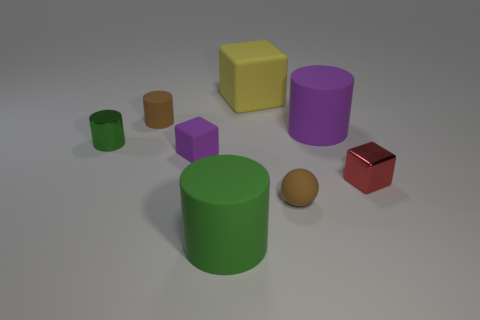There is a matte object that is to the left of the yellow matte cube and in front of the red metal thing; what is its color?
Make the answer very short. Green. There is a green thing that is in front of the red thing; how many green matte things are left of it?
Offer a terse response. 0. Is there a large metal thing that has the same shape as the big green rubber thing?
Keep it short and to the point. No. There is a small brown object in front of the small matte cylinder; does it have the same shape as the large purple thing on the right side of the tiny green shiny object?
Provide a short and direct response. No. How many objects are either red metallic cubes or purple rubber things?
Offer a very short reply. 3. There is a red metallic object that is the same shape as the yellow object; what is its size?
Ensure brevity in your answer.  Small. Are there more purple rubber cubes in front of the tiny brown sphere than purple cylinders?
Give a very brief answer. No. Is the material of the yellow object the same as the tiny purple cube?
Offer a terse response. Yes. How many things are purple objects to the left of the big purple object or small balls in front of the small matte cylinder?
Provide a short and direct response. 2. There is another matte thing that is the same shape as the large yellow object; what is its color?
Your response must be concise. Purple. 